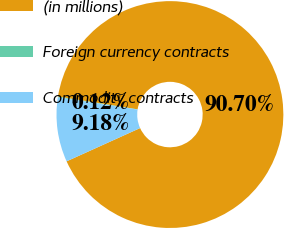<chart> <loc_0><loc_0><loc_500><loc_500><pie_chart><fcel>(in millions)<fcel>Foreign currency contracts<fcel>Commodity contracts<nl><fcel>90.71%<fcel>0.12%<fcel>9.18%<nl></chart> 